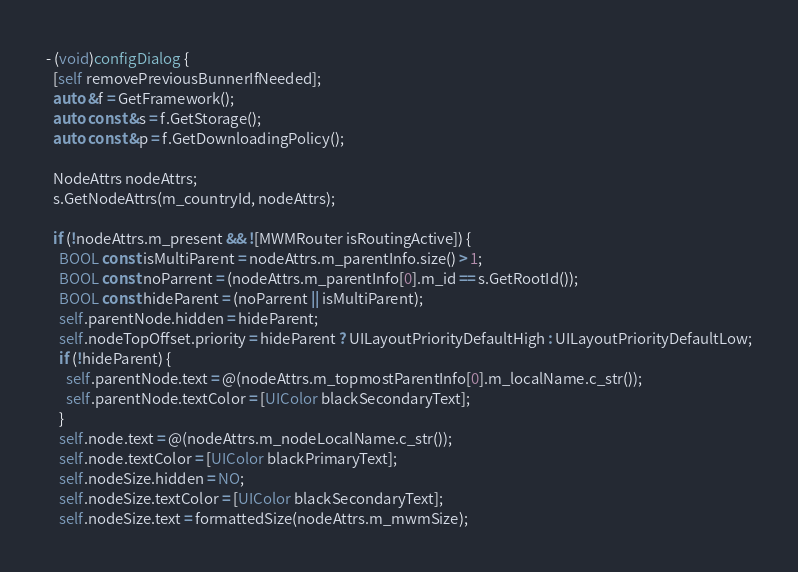Convert code to text. <code><loc_0><loc_0><loc_500><loc_500><_ObjectiveC_>
- (void)configDialog {
  [self removePreviousBunnerIfNeeded];
  auto &f = GetFramework();
  auto const &s = f.GetStorage();
  auto const &p = f.GetDownloadingPolicy();

  NodeAttrs nodeAttrs;
  s.GetNodeAttrs(m_countryId, nodeAttrs);

  if (!nodeAttrs.m_present && ![MWMRouter isRoutingActive]) {
    BOOL const isMultiParent = nodeAttrs.m_parentInfo.size() > 1;
    BOOL const noParrent = (nodeAttrs.m_parentInfo[0].m_id == s.GetRootId());
    BOOL const hideParent = (noParrent || isMultiParent);
    self.parentNode.hidden = hideParent;
    self.nodeTopOffset.priority = hideParent ? UILayoutPriorityDefaultHigh : UILayoutPriorityDefaultLow;
    if (!hideParent) {
      self.parentNode.text = @(nodeAttrs.m_topmostParentInfo[0].m_localName.c_str());
      self.parentNode.textColor = [UIColor blackSecondaryText];
    }
    self.node.text = @(nodeAttrs.m_nodeLocalName.c_str());
    self.node.textColor = [UIColor blackPrimaryText];
    self.nodeSize.hidden = NO;
    self.nodeSize.textColor = [UIColor blackSecondaryText];
    self.nodeSize.text = formattedSize(nodeAttrs.m_mwmSize);
</code> 